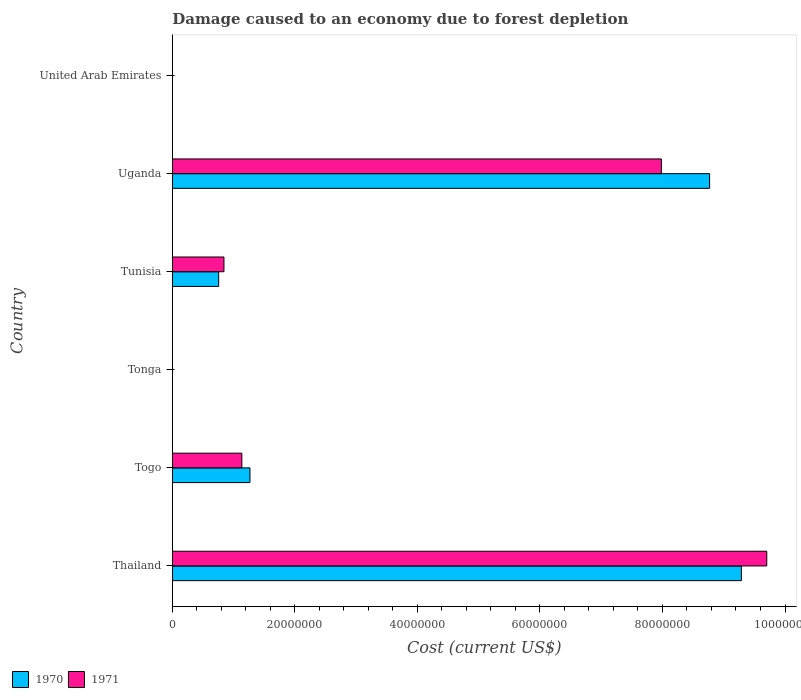How many groups of bars are there?
Your answer should be compact. 6. Are the number of bars on each tick of the Y-axis equal?
Give a very brief answer. Yes. What is the label of the 3rd group of bars from the top?
Provide a succinct answer. Tunisia. What is the cost of damage caused due to forest depletion in 1970 in Tunisia?
Provide a short and direct response. 7.56e+06. Across all countries, what is the maximum cost of damage caused due to forest depletion in 1971?
Make the answer very short. 9.70e+07. Across all countries, what is the minimum cost of damage caused due to forest depletion in 1971?
Provide a succinct answer. 4376.43. In which country was the cost of damage caused due to forest depletion in 1971 maximum?
Provide a succinct answer. Thailand. In which country was the cost of damage caused due to forest depletion in 1970 minimum?
Provide a short and direct response. Tonga. What is the total cost of damage caused due to forest depletion in 1970 in the graph?
Keep it short and to the point. 2.01e+08. What is the difference between the cost of damage caused due to forest depletion in 1970 in Togo and that in United Arab Emirates?
Provide a short and direct response. 1.27e+07. What is the difference between the cost of damage caused due to forest depletion in 1971 in United Arab Emirates and the cost of damage caused due to forest depletion in 1970 in Tunisia?
Your answer should be compact. -7.55e+06. What is the average cost of damage caused due to forest depletion in 1971 per country?
Provide a succinct answer. 3.28e+07. What is the difference between the cost of damage caused due to forest depletion in 1970 and cost of damage caused due to forest depletion in 1971 in Thailand?
Provide a succinct answer. -4.14e+06. In how many countries, is the cost of damage caused due to forest depletion in 1970 greater than 4000000 US$?
Offer a terse response. 4. What is the ratio of the cost of damage caused due to forest depletion in 1970 in Togo to that in Uganda?
Provide a short and direct response. 0.14. Is the cost of damage caused due to forest depletion in 1971 in Uganda less than that in United Arab Emirates?
Your answer should be very brief. No. What is the difference between the highest and the second highest cost of damage caused due to forest depletion in 1970?
Make the answer very short. 5.19e+06. What is the difference between the highest and the lowest cost of damage caused due to forest depletion in 1971?
Your answer should be very brief. 9.70e+07. Are the values on the major ticks of X-axis written in scientific E-notation?
Your answer should be compact. No. Does the graph contain grids?
Make the answer very short. No. How many legend labels are there?
Ensure brevity in your answer.  2. How are the legend labels stacked?
Make the answer very short. Horizontal. What is the title of the graph?
Your answer should be compact. Damage caused to an economy due to forest depletion. What is the label or title of the X-axis?
Your response must be concise. Cost (current US$). What is the Cost (current US$) of 1970 in Thailand?
Provide a succinct answer. 9.29e+07. What is the Cost (current US$) of 1971 in Thailand?
Your answer should be very brief. 9.70e+07. What is the Cost (current US$) of 1970 in Togo?
Make the answer very short. 1.27e+07. What is the Cost (current US$) in 1971 in Togo?
Ensure brevity in your answer.  1.13e+07. What is the Cost (current US$) of 1970 in Tonga?
Provide a succinct answer. 4901.94. What is the Cost (current US$) of 1971 in Tonga?
Offer a very short reply. 4376.43. What is the Cost (current US$) of 1970 in Tunisia?
Offer a terse response. 7.56e+06. What is the Cost (current US$) of 1971 in Tunisia?
Ensure brevity in your answer.  8.42e+06. What is the Cost (current US$) in 1970 in Uganda?
Your response must be concise. 8.77e+07. What is the Cost (current US$) of 1971 in Uganda?
Make the answer very short. 7.98e+07. What is the Cost (current US$) of 1970 in United Arab Emirates?
Ensure brevity in your answer.  5907.56. What is the Cost (current US$) in 1971 in United Arab Emirates?
Give a very brief answer. 4897.07. Across all countries, what is the maximum Cost (current US$) in 1970?
Keep it short and to the point. 9.29e+07. Across all countries, what is the maximum Cost (current US$) of 1971?
Provide a succinct answer. 9.70e+07. Across all countries, what is the minimum Cost (current US$) of 1970?
Make the answer very short. 4901.94. Across all countries, what is the minimum Cost (current US$) of 1971?
Provide a succinct answer. 4376.43. What is the total Cost (current US$) in 1970 in the graph?
Make the answer very short. 2.01e+08. What is the total Cost (current US$) of 1971 in the graph?
Offer a very short reply. 1.97e+08. What is the difference between the Cost (current US$) in 1970 in Thailand and that in Togo?
Your answer should be very brief. 8.02e+07. What is the difference between the Cost (current US$) of 1971 in Thailand and that in Togo?
Keep it short and to the point. 8.57e+07. What is the difference between the Cost (current US$) of 1970 in Thailand and that in Tonga?
Offer a terse response. 9.29e+07. What is the difference between the Cost (current US$) of 1971 in Thailand and that in Tonga?
Provide a short and direct response. 9.70e+07. What is the difference between the Cost (current US$) in 1970 in Thailand and that in Tunisia?
Your answer should be compact. 8.53e+07. What is the difference between the Cost (current US$) in 1971 in Thailand and that in Tunisia?
Offer a terse response. 8.86e+07. What is the difference between the Cost (current US$) in 1970 in Thailand and that in Uganda?
Provide a short and direct response. 5.19e+06. What is the difference between the Cost (current US$) of 1971 in Thailand and that in Uganda?
Your answer should be compact. 1.72e+07. What is the difference between the Cost (current US$) in 1970 in Thailand and that in United Arab Emirates?
Your response must be concise. 9.29e+07. What is the difference between the Cost (current US$) in 1971 in Thailand and that in United Arab Emirates?
Offer a terse response. 9.70e+07. What is the difference between the Cost (current US$) in 1970 in Togo and that in Tonga?
Ensure brevity in your answer.  1.27e+07. What is the difference between the Cost (current US$) in 1971 in Togo and that in Tonga?
Ensure brevity in your answer.  1.13e+07. What is the difference between the Cost (current US$) in 1970 in Togo and that in Tunisia?
Ensure brevity in your answer.  5.11e+06. What is the difference between the Cost (current US$) in 1971 in Togo and that in Tunisia?
Your response must be concise. 2.92e+06. What is the difference between the Cost (current US$) in 1970 in Togo and that in Uganda?
Keep it short and to the point. -7.50e+07. What is the difference between the Cost (current US$) of 1971 in Togo and that in Uganda?
Make the answer very short. -6.85e+07. What is the difference between the Cost (current US$) in 1970 in Togo and that in United Arab Emirates?
Your answer should be compact. 1.27e+07. What is the difference between the Cost (current US$) of 1971 in Togo and that in United Arab Emirates?
Offer a very short reply. 1.13e+07. What is the difference between the Cost (current US$) in 1970 in Tonga and that in Tunisia?
Offer a terse response. -7.55e+06. What is the difference between the Cost (current US$) in 1971 in Tonga and that in Tunisia?
Make the answer very short. -8.42e+06. What is the difference between the Cost (current US$) of 1970 in Tonga and that in Uganda?
Keep it short and to the point. -8.77e+07. What is the difference between the Cost (current US$) in 1971 in Tonga and that in Uganda?
Your answer should be very brief. -7.98e+07. What is the difference between the Cost (current US$) in 1970 in Tonga and that in United Arab Emirates?
Offer a very short reply. -1005.61. What is the difference between the Cost (current US$) of 1971 in Tonga and that in United Arab Emirates?
Your answer should be very brief. -520.64. What is the difference between the Cost (current US$) in 1970 in Tunisia and that in Uganda?
Provide a succinct answer. -8.01e+07. What is the difference between the Cost (current US$) of 1971 in Tunisia and that in Uganda?
Provide a succinct answer. -7.14e+07. What is the difference between the Cost (current US$) in 1970 in Tunisia and that in United Arab Emirates?
Your answer should be compact. 7.55e+06. What is the difference between the Cost (current US$) in 1971 in Tunisia and that in United Arab Emirates?
Your answer should be compact. 8.42e+06. What is the difference between the Cost (current US$) of 1970 in Uganda and that in United Arab Emirates?
Ensure brevity in your answer.  8.77e+07. What is the difference between the Cost (current US$) in 1971 in Uganda and that in United Arab Emirates?
Keep it short and to the point. 7.98e+07. What is the difference between the Cost (current US$) in 1970 in Thailand and the Cost (current US$) in 1971 in Togo?
Your answer should be very brief. 8.15e+07. What is the difference between the Cost (current US$) in 1970 in Thailand and the Cost (current US$) in 1971 in Tonga?
Give a very brief answer. 9.29e+07. What is the difference between the Cost (current US$) in 1970 in Thailand and the Cost (current US$) in 1971 in Tunisia?
Make the answer very short. 8.45e+07. What is the difference between the Cost (current US$) of 1970 in Thailand and the Cost (current US$) of 1971 in Uganda?
Ensure brevity in your answer.  1.31e+07. What is the difference between the Cost (current US$) in 1970 in Thailand and the Cost (current US$) in 1971 in United Arab Emirates?
Ensure brevity in your answer.  9.29e+07. What is the difference between the Cost (current US$) in 1970 in Togo and the Cost (current US$) in 1971 in Tonga?
Your answer should be compact. 1.27e+07. What is the difference between the Cost (current US$) in 1970 in Togo and the Cost (current US$) in 1971 in Tunisia?
Your answer should be very brief. 4.24e+06. What is the difference between the Cost (current US$) in 1970 in Togo and the Cost (current US$) in 1971 in Uganda?
Ensure brevity in your answer.  -6.72e+07. What is the difference between the Cost (current US$) in 1970 in Togo and the Cost (current US$) in 1971 in United Arab Emirates?
Keep it short and to the point. 1.27e+07. What is the difference between the Cost (current US$) in 1970 in Tonga and the Cost (current US$) in 1971 in Tunisia?
Your answer should be very brief. -8.42e+06. What is the difference between the Cost (current US$) of 1970 in Tonga and the Cost (current US$) of 1971 in Uganda?
Give a very brief answer. -7.98e+07. What is the difference between the Cost (current US$) in 1970 in Tonga and the Cost (current US$) in 1971 in United Arab Emirates?
Provide a succinct answer. 4.87. What is the difference between the Cost (current US$) of 1970 in Tunisia and the Cost (current US$) of 1971 in Uganda?
Provide a succinct answer. -7.23e+07. What is the difference between the Cost (current US$) in 1970 in Tunisia and the Cost (current US$) in 1971 in United Arab Emirates?
Your answer should be compact. 7.55e+06. What is the difference between the Cost (current US$) of 1970 in Uganda and the Cost (current US$) of 1971 in United Arab Emirates?
Keep it short and to the point. 8.77e+07. What is the average Cost (current US$) of 1970 per country?
Provide a short and direct response. 3.35e+07. What is the average Cost (current US$) of 1971 per country?
Provide a short and direct response. 3.28e+07. What is the difference between the Cost (current US$) of 1970 and Cost (current US$) of 1971 in Thailand?
Ensure brevity in your answer.  -4.14e+06. What is the difference between the Cost (current US$) in 1970 and Cost (current US$) in 1971 in Togo?
Your answer should be very brief. 1.32e+06. What is the difference between the Cost (current US$) of 1970 and Cost (current US$) of 1971 in Tonga?
Offer a terse response. 525.51. What is the difference between the Cost (current US$) in 1970 and Cost (current US$) in 1971 in Tunisia?
Your answer should be very brief. -8.66e+05. What is the difference between the Cost (current US$) of 1970 and Cost (current US$) of 1971 in Uganda?
Offer a terse response. 7.87e+06. What is the difference between the Cost (current US$) of 1970 and Cost (current US$) of 1971 in United Arab Emirates?
Make the answer very short. 1010.49. What is the ratio of the Cost (current US$) in 1970 in Thailand to that in Togo?
Offer a very short reply. 7.33. What is the ratio of the Cost (current US$) in 1971 in Thailand to that in Togo?
Offer a very short reply. 8.55. What is the ratio of the Cost (current US$) in 1970 in Thailand to that in Tonga?
Offer a very short reply. 1.89e+04. What is the ratio of the Cost (current US$) of 1971 in Thailand to that in Tonga?
Keep it short and to the point. 2.22e+04. What is the ratio of the Cost (current US$) of 1970 in Thailand to that in Tunisia?
Your answer should be compact. 12.29. What is the ratio of the Cost (current US$) of 1971 in Thailand to that in Tunisia?
Make the answer very short. 11.52. What is the ratio of the Cost (current US$) in 1970 in Thailand to that in Uganda?
Provide a succinct answer. 1.06. What is the ratio of the Cost (current US$) of 1971 in Thailand to that in Uganda?
Make the answer very short. 1.22. What is the ratio of the Cost (current US$) of 1970 in Thailand to that in United Arab Emirates?
Your answer should be compact. 1.57e+04. What is the ratio of the Cost (current US$) in 1971 in Thailand to that in United Arab Emirates?
Make the answer very short. 1.98e+04. What is the ratio of the Cost (current US$) of 1970 in Togo to that in Tonga?
Your answer should be compact. 2583.92. What is the ratio of the Cost (current US$) of 1971 in Togo to that in Tonga?
Give a very brief answer. 2592.16. What is the ratio of the Cost (current US$) in 1970 in Togo to that in Tunisia?
Ensure brevity in your answer.  1.68. What is the ratio of the Cost (current US$) in 1971 in Togo to that in Tunisia?
Offer a very short reply. 1.35. What is the ratio of the Cost (current US$) in 1970 in Togo to that in Uganda?
Provide a short and direct response. 0.14. What is the ratio of the Cost (current US$) of 1971 in Togo to that in Uganda?
Give a very brief answer. 0.14. What is the ratio of the Cost (current US$) of 1970 in Togo to that in United Arab Emirates?
Your answer should be compact. 2144.07. What is the ratio of the Cost (current US$) of 1971 in Togo to that in United Arab Emirates?
Provide a short and direct response. 2316.57. What is the ratio of the Cost (current US$) of 1970 in Tonga to that in Tunisia?
Offer a very short reply. 0. What is the ratio of the Cost (current US$) in 1971 in Tonga to that in Tunisia?
Give a very brief answer. 0. What is the ratio of the Cost (current US$) of 1970 in Tonga to that in United Arab Emirates?
Make the answer very short. 0.83. What is the ratio of the Cost (current US$) of 1971 in Tonga to that in United Arab Emirates?
Give a very brief answer. 0.89. What is the ratio of the Cost (current US$) of 1970 in Tunisia to that in Uganda?
Provide a short and direct response. 0.09. What is the ratio of the Cost (current US$) in 1971 in Tunisia to that in Uganda?
Offer a very short reply. 0.11. What is the ratio of the Cost (current US$) of 1970 in Tunisia to that in United Arab Emirates?
Keep it short and to the point. 1279.34. What is the ratio of the Cost (current US$) in 1971 in Tunisia to that in United Arab Emirates?
Your response must be concise. 1720.12. What is the ratio of the Cost (current US$) of 1970 in Uganda to that in United Arab Emirates?
Provide a short and direct response. 1.48e+04. What is the ratio of the Cost (current US$) of 1971 in Uganda to that in United Arab Emirates?
Ensure brevity in your answer.  1.63e+04. What is the difference between the highest and the second highest Cost (current US$) in 1970?
Provide a succinct answer. 5.19e+06. What is the difference between the highest and the second highest Cost (current US$) of 1971?
Keep it short and to the point. 1.72e+07. What is the difference between the highest and the lowest Cost (current US$) of 1970?
Offer a very short reply. 9.29e+07. What is the difference between the highest and the lowest Cost (current US$) of 1971?
Your answer should be compact. 9.70e+07. 